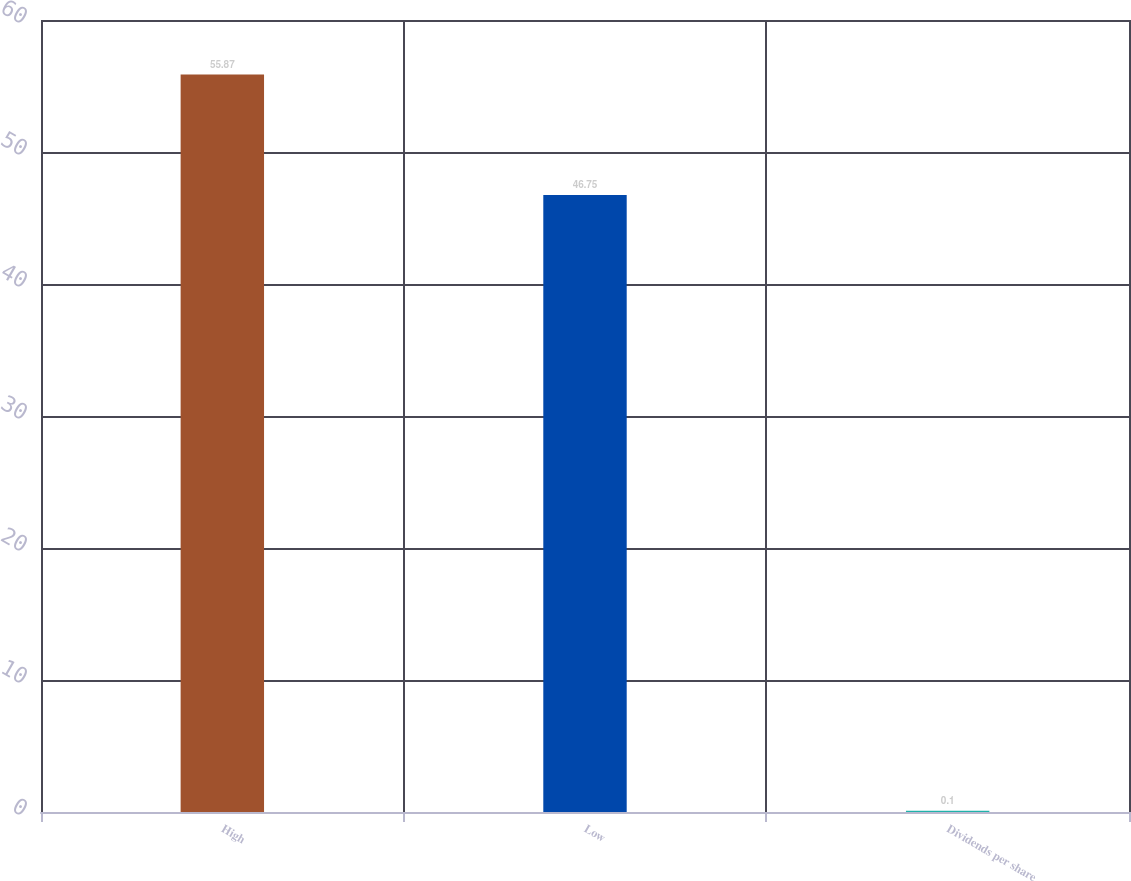Convert chart to OTSL. <chart><loc_0><loc_0><loc_500><loc_500><bar_chart><fcel>High<fcel>Low<fcel>Dividends per share<nl><fcel>55.87<fcel>46.75<fcel>0.1<nl></chart> 